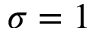<formula> <loc_0><loc_0><loc_500><loc_500>\sigma = 1</formula> 